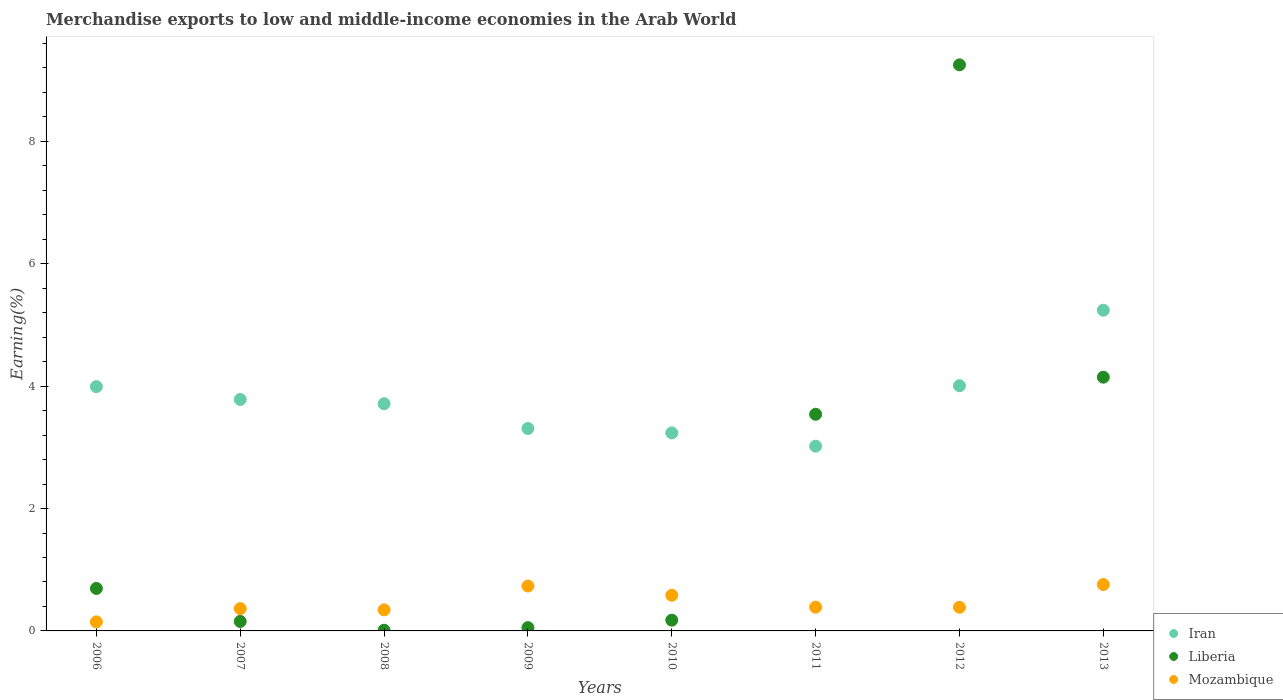What is the percentage of amount earned from merchandise exports in Mozambique in 2006?
Your answer should be compact. 0.15. Across all years, what is the maximum percentage of amount earned from merchandise exports in Mozambique?
Offer a terse response. 0.76. Across all years, what is the minimum percentage of amount earned from merchandise exports in Iran?
Keep it short and to the point. 3.02. In which year was the percentage of amount earned from merchandise exports in Mozambique minimum?
Keep it short and to the point. 2006. What is the total percentage of amount earned from merchandise exports in Liberia in the graph?
Give a very brief answer. 18.03. What is the difference between the percentage of amount earned from merchandise exports in Iran in 2007 and that in 2010?
Offer a very short reply. 0.55. What is the difference between the percentage of amount earned from merchandise exports in Mozambique in 2006 and the percentage of amount earned from merchandise exports in Liberia in 2008?
Your response must be concise. 0.14. What is the average percentage of amount earned from merchandise exports in Mozambique per year?
Provide a succinct answer. 0.46. In the year 2011, what is the difference between the percentage of amount earned from merchandise exports in Mozambique and percentage of amount earned from merchandise exports in Liberia?
Provide a succinct answer. -3.15. What is the ratio of the percentage of amount earned from merchandise exports in Mozambique in 2007 to that in 2013?
Provide a succinct answer. 0.48. What is the difference between the highest and the second highest percentage of amount earned from merchandise exports in Mozambique?
Offer a terse response. 0.02. What is the difference between the highest and the lowest percentage of amount earned from merchandise exports in Liberia?
Offer a very short reply. 9.24. Is it the case that in every year, the sum of the percentage of amount earned from merchandise exports in Iran and percentage of amount earned from merchandise exports in Mozambique  is greater than the percentage of amount earned from merchandise exports in Liberia?
Provide a short and direct response. No. Is the percentage of amount earned from merchandise exports in Mozambique strictly greater than the percentage of amount earned from merchandise exports in Iran over the years?
Offer a terse response. No. How many years are there in the graph?
Provide a succinct answer. 8. What is the difference between two consecutive major ticks on the Y-axis?
Give a very brief answer. 2. Where does the legend appear in the graph?
Ensure brevity in your answer.  Bottom right. How many legend labels are there?
Give a very brief answer. 3. What is the title of the graph?
Give a very brief answer. Merchandise exports to low and middle-income economies in the Arab World. Does "Least developed countries" appear as one of the legend labels in the graph?
Offer a terse response. No. What is the label or title of the X-axis?
Your answer should be very brief. Years. What is the label or title of the Y-axis?
Your response must be concise. Earning(%). What is the Earning(%) in Iran in 2006?
Give a very brief answer. 3.99. What is the Earning(%) in Liberia in 2006?
Offer a terse response. 0.69. What is the Earning(%) of Mozambique in 2006?
Make the answer very short. 0.15. What is the Earning(%) of Iran in 2007?
Offer a very short reply. 3.78. What is the Earning(%) of Liberia in 2007?
Offer a terse response. 0.15. What is the Earning(%) of Mozambique in 2007?
Make the answer very short. 0.36. What is the Earning(%) in Iran in 2008?
Make the answer very short. 3.71. What is the Earning(%) of Liberia in 2008?
Offer a terse response. 0.01. What is the Earning(%) of Mozambique in 2008?
Your answer should be compact. 0.34. What is the Earning(%) in Iran in 2009?
Make the answer very short. 3.31. What is the Earning(%) in Liberia in 2009?
Offer a terse response. 0.05. What is the Earning(%) of Mozambique in 2009?
Make the answer very short. 0.73. What is the Earning(%) of Iran in 2010?
Provide a short and direct response. 3.24. What is the Earning(%) in Liberia in 2010?
Provide a short and direct response. 0.18. What is the Earning(%) in Mozambique in 2010?
Give a very brief answer. 0.58. What is the Earning(%) in Iran in 2011?
Give a very brief answer. 3.02. What is the Earning(%) of Liberia in 2011?
Your answer should be compact. 3.54. What is the Earning(%) in Mozambique in 2011?
Your response must be concise. 0.39. What is the Earning(%) of Iran in 2012?
Keep it short and to the point. 4.01. What is the Earning(%) of Liberia in 2012?
Give a very brief answer. 9.25. What is the Earning(%) in Mozambique in 2012?
Offer a terse response. 0.39. What is the Earning(%) in Iran in 2013?
Ensure brevity in your answer.  5.24. What is the Earning(%) of Liberia in 2013?
Offer a terse response. 4.15. What is the Earning(%) in Mozambique in 2013?
Provide a short and direct response. 0.76. Across all years, what is the maximum Earning(%) of Iran?
Keep it short and to the point. 5.24. Across all years, what is the maximum Earning(%) of Liberia?
Offer a very short reply. 9.25. Across all years, what is the maximum Earning(%) in Mozambique?
Offer a very short reply. 0.76. Across all years, what is the minimum Earning(%) in Iran?
Offer a very short reply. 3.02. Across all years, what is the minimum Earning(%) of Liberia?
Keep it short and to the point. 0.01. Across all years, what is the minimum Earning(%) of Mozambique?
Ensure brevity in your answer.  0.15. What is the total Earning(%) in Iran in the graph?
Make the answer very short. 30.3. What is the total Earning(%) in Liberia in the graph?
Make the answer very short. 18.03. What is the total Earning(%) of Mozambique in the graph?
Ensure brevity in your answer.  3.71. What is the difference between the Earning(%) of Iran in 2006 and that in 2007?
Offer a terse response. 0.21. What is the difference between the Earning(%) in Liberia in 2006 and that in 2007?
Provide a succinct answer. 0.54. What is the difference between the Earning(%) of Mozambique in 2006 and that in 2007?
Provide a succinct answer. -0.22. What is the difference between the Earning(%) in Iran in 2006 and that in 2008?
Ensure brevity in your answer.  0.28. What is the difference between the Earning(%) of Liberia in 2006 and that in 2008?
Your answer should be very brief. 0.68. What is the difference between the Earning(%) of Mozambique in 2006 and that in 2008?
Offer a terse response. -0.2. What is the difference between the Earning(%) in Iran in 2006 and that in 2009?
Keep it short and to the point. 0.68. What is the difference between the Earning(%) in Liberia in 2006 and that in 2009?
Your answer should be compact. 0.64. What is the difference between the Earning(%) of Mozambique in 2006 and that in 2009?
Offer a terse response. -0.59. What is the difference between the Earning(%) in Iran in 2006 and that in 2010?
Offer a terse response. 0.76. What is the difference between the Earning(%) in Liberia in 2006 and that in 2010?
Your response must be concise. 0.52. What is the difference between the Earning(%) of Mozambique in 2006 and that in 2010?
Your response must be concise. -0.43. What is the difference between the Earning(%) of Iran in 2006 and that in 2011?
Offer a very short reply. 0.97. What is the difference between the Earning(%) of Liberia in 2006 and that in 2011?
Make the answer very short. -2.85. What is the difference between the Earning(%) in Mozambique in 2006 and that in 2011?
Provide a short and direct response. -0.24. What is the difference between the Earning(%) in Iran in 2006 and that in 2012?
Ensure brevity in your answer.  -0.01. What is the difference between the Earning(%) of Liberia in 2006 and that in 2012?
Provide a short and direct response. -8.56. What is the difference between the Earning(%) in Mozambique in 2006 and that in 2012?
Keep it short and to the point. -0.24. What is the difference between the Earning(%) in Iran in 2006 and that in 2013?
Give a very brief answer. -1.25. What is the difference between the Earning(%) of Liberia in 2006 and that in 2013?
Keep it short and to the point. -3.45. What is the difference between the Earning(%) of Mozambique in 2006 and that in 2013?
Make the answer very short. -0.61. What is the difference between the Earning(%) of Iran in 2007 and that in 2008?
Ensure brevity in your answer.  0.07. What is the difference between the Earning(%) in Liberia in 2007 and that in 2008?
Provide a short and direct response. 0.14. What is the difference between the Earning(%) in Mozambique in 2007 and that in 2008?
Provide a short and direct response. 0.02. What is the difference between the Earning(%) of Iran in 2007 and that in 2009?
Ensure brevity in your answer.  0.47. What is the difference between the Earning(%) in Liberia in 2007 and that in 2009?
Ensure brevity in your answer.  0.1. What is the difference between the Earning(%) in Mozambique in 2007 and that in 2009?
Provide a succinct answer. -0.37. What is the difference between the Earning(%) of Iran in 2007 and that in 2010?
Make the answer very short. 0.55. What is the difference between the Earning(%) of Liberia in 2007 and that in 2010?
Ensure brevity in your answer.  -0.02. What is the difference between the Earning(%) in Mozambique in 2007 and that in 2010?
Your answer should be compact. -0.22. What is the difference between the Earning(%) in Iran in 2007 and that in 2011?
Keep it short and to the point. 0.76. What is the difference between the Earning(%) in Liberia in 2007 and that in 2011?
Offer a terse response. -3.39. What is the difference between the Earning(%) of Mozambique in 2007 and that in 2011?
Make the answer very short. -0.02. What is the difference between the Earning(%) in Iran in 2007 and that in 2012?
Provide a succinct answer. -0.22. What is the difference between the Earning(%) in Liberia in 2007 and that in 2012?
Keep it short and to the point. -9.1. What is the difference between the Earning(%) in Mozambique in 2007 and that in 2012?
Keep it short and to the point. -0.02. What is the difference between the Earning(%) of Iran in 2007 and that in 2013?
Offer a terse response. -1.46. What is the difference between the Earning(%) of Liberia in 2007 and that in 2013?
Provide a succinct answer. -3.99. What is the difference between the Earning(%) in Mozambique in 2007 and that in 2013?
Offer a terse response. -0.39. What is the difference between the Earning(%) of Iran in 2008 and that in 2009?
Your answer should be very brief. 0.4. What is the difference between the Earning(%) in Liberia in 2008 and that in 2009?
Make the answer very short. -0.04. What is the difference between the Earning(%) in Mozambique in 2008 and that in 2009?
Give a very brief answer. -0.39. What is the difference between the Earning(%) of Iran in 2008 and that in 2010?
Your answer should be compact. 0.48. What is the difference between the Earning(%) in Liberia in 2008 and that in 2010?
Offer a very short reply. -0.16. What is the difference between the Earning(%) in Mozambique in 2008 and that in 2010?
Your answer should be very brief. -0.24. What is the difference between the Earning(%) of Iran in 2008 and that in 2011?
Make the answer very short. 0.69. What is the difference between the Earning(%) in Liberia in 2008 and that in 2011?
Provide a succinct answer. -3.53. What is the difference between the Earning(%) of Mozambique in 2008 and that in 2011?
Your response must be concise. -0.04. What is the difference between the Earning(%) in Iran in 2008 and that in 2012?
Provide a succinct answer. -0.29. What is the difference between the Earning(%) of Liberia in 2008 and that in 2012?
Offer a terse response. -9.24. What is the difference between the Earning(%) in Mozambique in 2008 and that in 2012?
Keep it short and to the point. -0.04. What is the difference between the Earning(%) of Iran in 2008 and that in 2013?
Offer a very short reply. -1.53. What is the difference between the Earning(%) in Liberia in 2008 and that in 2013?
Your answer should be very brief. -4.13. What is the difference between the Earning(%) of Mozambique in 2008 and that in 2013?
Your answer should be very brief. -0.41. What is the difference between the Earning(%) of Iran in 2009 and that in 2010?
Offer a very short reply. 0.07. What is the difference between the Earning(%) of Liberia in 2009 and that in 2010?
Give a very brief answer. -0.12. What is the difference between the Earning(%) of Mozambique in 2009 and that in 2010?
Offer a terse response. 0.15. What is the difference between the Earning(%) of Iran in 2009 and that in 2011?
Your response must be concise. 0.29. What is the difference between the Earning(%) in Liberia in 2009 and that in 2011?
Provide a short and direct response. -3.49. What is the difference between the Earning(%) in Mozambique in 2009 and that in 2011?
Your answer should be very brief. 0.34. What is the difference between the Earning(%) of Iran in 2009 and that in 2012?
Ensure brevity in your answer.  -0.7. What is the difference between the Earning(%) in Liberia in 2009 and that in 2012?
Your answer should be compact. -9.2. What is the difference between the Earning(%) of Mozambique in 2009 and that in 2012?
Provide a succinct answer. 0.35. What is the difference between the Earning(%) of Iran in 2009 and that in 2013?
Ensure brevity in your answer.  -1.93. What is the difference between the Earning(%) of Liberia in 2009 and that in 2013?
Your response must be concise. -4.09. What is the difference between the Earning(%) of Mozambique in 2009 and that in 2013?
Your response must be concise. -0.02. What is the difference between the Earning(%) of Iran in 2010 and that in 2011?
Provide a succinct answer. 0.22. What is the difference between the Earning(%) of Liberia in 2010 and that in 2011?
Make the answer very short. -3.37. What is the difference between the Earning(%) of Mozambique in 2010 and that in 2011?
Your answer should be compact. 0.19. What is the difference between the Earning(%) in Iran in 2010 and that in 2012?
Give a very brief answer. -0.77. What is the difference between the Earning(%) in Liberia in 2010 and that in 2012?
Give a very brief answer. -9.08. What is the difference between the Earning(%) of Mozambique in 2010 and that in 2012?
Ensure brevity in your answer.  0.2. What is the difference between the Earning(%) in Iran in 2010 and that in 2013?
Your response must be concise. -2. What is the difference between the Earning(%) in Liberia in 2010 and that in 2013?
Your answer should be very brief. -3.97. What is the difference between the Earning(%) of Mozambique in 2010 and that in 2013?
Your answer should be very brief. -0.18. What is the difference between the Earning(%) of Iran in 2011 and that in 2012?
Make the answer very short. -0.99. What is the difference between the Earning(%) of Liberia in 2011 and that in 2012?
Offer a terse response. -5.71. What is the difference between the Earning(%) of Mozambique in 2011 and that in 2012?
Give a very brief answer. 0. What is the difference between the Earning(%) of Iran in 2011 and that in 2013?
Offer a very short reply. -2.22. What is the difference between the Earning(%) in Liberia in 2011 and that in 2013?
Give a very brief answer. -0.61. What is the difference between the Earning(%) of Mozambique in 2011 and that in 2013?
Give a very brief answer. -0.37. What is the difference between the Earning(%) in Iran in 2012 and that in 2013?
Keep it short and to the point. -1.23. What is the difference between the Earning(%) of Liberia in 2012 and that in 2013?
Keep it short and to the point. 5.1. What is the difference between the Earning(%) in Mozambique in 2012 and that in 2013?
Provide a short and direct response. -0.37. What is the difference between the Earning(%) of Iran in 2006 and the Earning(%) of Liberia in 2007?
Make the answer very short. 3.84. What is the difference between the Earning(%) of Iran in 2006 and the Earning(%) of Mozambique in 2007?
Keep it short and to the point. 3.63. What is the difference between the Earning(%) in Liberia in 2006 and the Earning(%) in Mozambique in 2007?
Ensure brevity in your answer.  0.33. What is the difference between the Earning(%) of Iran in 2006 and the Earning(%) of Liberia in 2008?
Give a very brief answer. 3.98. What is the difference between the Earning(%) of Iran in 2006 and the Earning(%) of Mozambique in 2008?
Your answer should be compact. 3.65. What is the difference between the Earning(%) in Liberia in 2006 and the Earning(%) in Mozambique in 2008?
Provide a succinct answer. 0.35. What is the difference between the Earning(%) in Iran in 2006 and the Earning(%) in Liberia in 2009?
Ensure brevity in your answer.  3.94. What is the difference between the Earning(%) in Iran in 2006 and the Earning(%) in Mozambique in 2009?
Offer a terse response. 3.26. What is the difference between the Earning(%) in Liberia in 2006 and the Earning(%) in Mozambique in 2009?
Provide a short and direct response. -0.04. What is the difference between the Earning(%) of Iran in 2006 and the Earning(%) of Liberia in 2010?
Keep it short and to the point. 3.82. What is the difference between the Earning(%) of Iran in 2006 and the Earning(%) of Mozambique in 2010?
Make the answer very short. 3.41. What is the difference between the Earning(%) of Liberia in 2006 and the Earning(%) of Mozambique in 2010?
Your answer should be compact. 0.11. What is the difference between the Earning(%) of Iran in 2006 and the Earning(%) of Liberia in 2011?
Your response must be concise. 0.45. What is the difference between the Earning(%) in Iran in 2006 and the Earning(%) in Mozambique in 2011?
Offer a terse response. 3.6. What is the difference between the Earning(%) of Liberia in 2006 and the Earning(%) of Mozambique in 2011?
Provide a short and direct response. 0.31. What is the difference between the Earning(%) in Iran in 2006 and the Earning(%) in Liberia in 2012?
Provide a short and direct response. -5.26. What is the difference between the Earning(%) in Iran in 2006 and the Earning(%) in Mozambique in 2012?
Your answer should be very brief. 3.61. What is the difference between the Earning(%) of Liberia in 2006 and the Earning(%) of Mozambique in 2012?
Provide a short and direct response. 0.31. What is the difference between the Earning(%) in Iran in 2006 and the Earning(%) in Liberia in 2013?
Your answer should be very brief. -0.15. What is the difference between the Earning(%) of Iran in 2006 and the Earning(%) of Mozambique in 2013?
Offer a terse response. 3.23. What is the difference between the Earning(%) in Liberia in 2006 and the Earning(%) in Mozambique in 2013?
Keep it short and to the point. -0.06. What is the difference between the Earning(%) in Iran in 2007 and the Earning(%) in Liberia in 2008?
Offer a very short reply. 3.77. What is the difference between the Earning(%) of Iran in 2007 and the Earning(%) of Mozambique in 2008?
Your response must be concise. 3.44. What is the difference between the Earning(%) of Liberia in 2007 and the Earning(%) of Mozambique in 2008?
Your response must be concise. -0.19. What is the difference between the Earning(%) in Iran in 2007 and the Earning(%) in Liberia in 2009?
Ensure brevity in your answer.  3.73. What is the difference between the Earning(%) of Iran in 2007 and the Earning(%) of Mozambique in 2009?
Your response must be concise. 3.05. What is the difference between the Earning(%) of Liberia in 2007 and the Earning(%) of Mozambique in 2009?
Keep it short and to the point. -0.58. What is the difference between the Earning(%) in Iran in 2007 and the Earning(%) in Liberia in 2010?
Make the answer very short. 3.61. What is the difference between the Earning(%) in Iran in 2007 and the Earning(%) in Mozambique in 2010?
Your answer should be very brief. 3.2. What is the difference between the Earning(%) of Liberia in 2007 and the Earning(%) of Mozambique in 2010?
Offer a terse response. -0.43. What is the difference between the Earning(%) of Iran in 2007 and the Earning(%) of Liberia in 2011?
Give a very brief answer. 0.24. What is the difference between the Earning(%) in Iran in 2007 and the Earning(%) in Mozambique in 2011?
Ensure brevity in your answer.  3.39. What is the difference between the Earning(%) in Liberia in 2007 and the Earning(%) in Mozambique in 2011?
Offer a very short reply. -0.23. What is the difference between the Earning(%) of Iran in 2007 and the Earning(%) of Liberia in 2012?
Keep it short and to the point. -5.47. What is the difference between the Earning(%) of Iran in 2007 and the Earning(%) of Mozambique in 2012?
Offer a very short reply. 3.4. What is the difference between the Earning(%) of Liberia in 2007 and the Earning(%) of Mozambique in 2012?
Your answer should be very brief. -0.23. What is the difference between the Earning(%) of Iran in 2007 and the Earning(%) of Liberia in 2013?
Your answer should be compact. -0.36. What is the difference between the Earning(%) of Iran in 2007 and the Earning(%) of Mozambique in 2013?
Provide a succinct answer. 3.02. What is the difference between the Earning(%) in Liberia in 2007 and the Earning(%) in Mozambique in 2013?
Keep it short and to the point. -0.6. What is the difference between the Earning(%) of Iran in 2008 and the Earning(%) of Liberia in 2009?
Provide a short and direct response. 3.66. What is the difference between the Earning(%) in Iran in 2008 and the Earning(%) in Mozambique in 2009?
Your answer should be compact. 2.98. What is the difference between the Earning(%) of Liberia in 2008 and the Earning(%) of Mozambique in 2009?
Give a very brief answer. -0.72. What is the difference between the Earning(%) of Iran in 2008 and the Earning(%) of Liberia in 2010?
Provide a succinct answer. 3.54. What is the difference between the Earning(%) in Iran in 2008 and the Earning(%) in Mozambique in 2010?
Provide a succinct answer. 3.13. What is the difference between the Earning(%) in Liberia in 2008 and the Earning(%) in Mozambique in 2010?
Provide a succinct answer. -0.57. What is the difference between the Earning(%) of Iran in 2008 and the Earning(%) of Liberia in 2011?
Your answer should be compact. 0.17. What is the difference between the Earning(%) of Iran in 2008 and the Earning(%) of Mozambique in 2011?
Offer a terse response. 3.32. What is the difference between the Earning(%) in Liberia in 2008 and the Earning(%) in Mozambique in 2011?
Give a very brief answer. -0.38. What is the difference between the Earning(%) of Iran in 2008 and the Earning(%) of Liberia in 2012?
Your answer should be very brief. -5.54. What is the difference between the Earning(%) in Iran in 2008 and the Earning(%) in Mozambique in 2012?
Offer a very short reply. 3.33. What is the difference between the Earning(%) in Liberia in 2008 and the Earning(%) in Mozambique in 2012?
Ensure brevity in your answer.  -0.37. What is the difference between the Earning(%) of Iran in 2008 and the Earning(%) of Liberia in 2013?
Give a very brief answer. -0.43. What is the difference between the Earning(%) of Iran in 2008 and the Earning(%) of Mozambique in 2013?
Offer a terse response. 2.95. What is the difference between the Earning(%) in Liberia in 2008 and the Earning(%) in Mozambique in 2013?
Provide a short and direct response. -0.75. What is the difference between the Earning(%) of Iran in 2009 and the Earning(%) of Liberia in 2010?
Make the answer very short. 3.13. What is the difference between the Earning(%) in Iran in 2009 and the Earning(%) in Mozambique in 2010?
Keep it short and to the point. 2.73. What is the difference between the Earning(%) of Liberia in 2009 and the Earning(%) of Mozambique in 2010?
Your response must be concise. -0.53. What is the difference between the Earning(%) in Iran in 2009 and the Earning(%) in Liberia in 2011?
Provide a succinct answer. -0.23. What is the difference between the Earning(%) of Iran in 2009 and the Earning(%) of Mozambique in 2011?
Your answer should be compact. 2.92. What is the difference between the Earning(%) of Liberia in 2009 and the Earning(%) of Mozambique in 2011?
Ensure brevity in your answer.  -0.34. What is the difference between the Earning(%) in Iran in 2009 and the Earning(%) in Liberia in 2012?
Your response must be concise. -5.94. What is the difference between the Earning(%) in Iran in 2009 and the Earning(%) in Mozambique in 2012?
Ensure brevity in your answer.  2.92. What is the difference between the Earning(%) in Liberia in 2009 and the Earning(%) in Mozambique in 2012?
Your response must be concise. -0.33. What is the difference between the Earning(%) in Iran in 2009 and the Earning(%) in Liberia in 2013?
Make the answer very short. -0.84. What is the difference between the Earning(%) in Iran in 2009 and the Earning(%) in Mozambique in 2013?
Offer a terse response. 2.55. What is the difference between the Earning(%) of Liberia in 2009 and the Earning(%) of Mozambique in 2013?
Offer a terse response. -0.7. What is the difference between the Earning(%) in Iran in 2010 and the Earning(%) in Liberia in 2011?
Your response must be concise. -0.3. What is the difference between the Earning(%) of Iran in 2010 and the Earning(%) of Mozambique in 2011?
Provide a short and direct response. 2.85. What is the difference between the Earning(%) of Liberia in 2010 and the Earning(%) of Mozambique in 2011?
Give a very brief answer. -0.21. What is the difference between the Earning(%) of Iran in 2010 and the Earning(%) of Liberia in 2012?
Make the answer very short. -6.01. What is the difference between the Earning(%) of Iran in 2010 and the Earning(%) of Mozambique in 2012?
Provide a short and direct response. 2.85. What is the difference between the Earning(%) of Liberia in 2010 and the Earning(%) of Mozambique in 2012?
Ensure brevity in your answer.  -0.21. What is the difference between the Earning(%) of Iran in 2010 and the Earning(%) of Liberia in 2013?
Offer a very short reply. -0.91. What is the difference between the Earning(%) in Iran in 2010 and the Earning(%) in Mozambique in 2013?
Your response must be concise. 2.48. What is the difference between the Earning(%) in Liberia in 2010 and the Earning(%) in Mozambique in 2013?
Your answer should be very brief. -0.58. What is the difference between the Earning(%) of Iran in 2011 and the Earning(%) of Liberia in 2012?
Your answer should be compact. -6.23. What is the difference between the Earning(%) of Iran in 2011 and the Earning(%) of Mozambique in 2012?
Ensure brevity in your answer.  2.63. What is the difference between the Earning(%) of Liberia in 2011 and the Earning(%) of Mozambique in 2012?
Your answer should be compact. 3.15. What is the difference between the Earning(%) in Iran in 2011 and the Earning(%) in Liberia in 2013?
Offer a terse response. -1.13. What is the difference between the Earning(%) of Iran in 2011 and the Earning(%) of Mozambique in 2013?
Your answer should be very brief. 2.26. What is the difference between the Earning(%) in Liberia in 2011 and the Earning(%) in Mozambique in 2013?
Keep it short and to the point. 2.78. What is the difference between the Earning(%) in Iran in 2012 and the Earning(%) in Liberia in 2013?
Offer a terse response. -0.14. What is the difference between the Earning(%) of Iran in 2012 and the Earning(%) of Mozambique in 2013?
Keep it short and to the point. 3.25. What is the difference between the Earning(%) of Liberia in 2012 and the Earning(%) of Mozambique in 2013?
Your answer should be compact. 8.49. What is the average Earning(%) in Iran per year?
Make the answer very short. 3.79. What is the average Earning(%) in Liberia per year?
Offer a terse response. 2.25. What is the average Earning(%) in Mozambique per year?
Ensure brevity in your answer.  0.46. In the year 2006, what is the difference between the Earning(%) in Iran and Earning(%) in Liberia?
Keep it short and to the point. 3.3. In the year 2006, what is the difference between the Earning(%) in Iran and Earning(%) in Mozambique?
Offer a very short reply. 3.84. In the year 2006, what is the difference between the Earning(%) of Liberia and Earning(%) of Mozambique?
Keep it short and to the point. 0.55. In the year 2007, what is the difference between the Earning(%) of Iran and Earning(%) of Liberia?
Keep it short and to the point. 3.63. In the year 2007, what is the difference between the Earning(%) of Iran and Earning(%) of Mozambique?
Offer a very short reply. 3.42. In the year 2007, what is the difference between the Earning(%) of Liberia and Earning(%) of Mozambique?
Make the answer very short. -0.21. In the year 2008, what is the difference between the Earning(%) in Iran and Earning(%) in Liberia?
Provide a succinct answer. 3.7. In the year 2008, what is the difference between the Earning(%) of Iran and Earning(%) of Mozambique?
Ensure brevity in your answer.  3.37. In the year 2008, what is the difference between the Earning(%) of Liberia and Earning(%) of Mozambique?
Keep it short and to the point. -0.33. In the year 2009, what is the difference between the Earning(%) of Iran and Earning(%) of Liberia?
Your answer should be very brief. 3.25. In the year 2009, what is the difference between the Earning(%) in Iran and Earning(%) in Mozambique?
Keep it short and to the point. 2.57. In the year 2009, what is the difference between the Earning(%) of Liberia and Earning(%) of Mozambique?
Ensure brevity in your answer.  -0.68. In the year 2010, what is the difference between the Earning(%) of Iran and Earning(%) of Liberia?
Make the answer very short. 3.06. In the year 2010, what is the difference between the Earning(%) of Iran and Earning(%) of Mozambique?
Ensure brevity in your answer.  2.65. In the year 2010, what is the difference between the Earning(%) in Liberia and Earning(%) in Mozambique?
Offer a terse response. -0.41. In the year 2011, what is the difference between the Earning(%) of Iran and Earning(%) of Liberia?
Make the answer very short. -0.52. In the year 2011, what is the difference between the Earning(%) in Iran and Earning(%) in Mozambique?
Offer a very short reply. 2.63. In the year 2011, what is the difference between the Earning(%) of Liberia and Earning(%) of Mozambique?
Provide a succinct answer. 3.15. In the year 2012, what is the difference between the Earning(%) in Iran and Earning(%) in Liberia?
Provide a succinct answer. -5.24. In the year 2012, what is the difference between the Earning(%) in Iran and Earning(%) in Mozambique?
Offer a very short reply. 3.62. In the year 2012, what is the difference between the Earning(%) in Liberia and Earning(%) in Mozambique?
Give a very brief answer. 8.86. In the year 2013, what is the difference between the Earning(%) of Iran and Earning(%) of Liberia?
Offer a very short reply. 1.09. In the year 2013, what is the difference between the Earning(%) of Iran and Earning(%) of Mozambique?
Offer a very short reply. 4.48. In the year 2013, what is the difference between the Earning(%) in Liberia and Earning(%) in Mozambique?
Keep it short and to the point. 3.39. What is the ratio of the Earning(%) in Iran in 2006 to that in 2007?
Keep it short and to the point. 1.06. What is the ratio of the Earning(%) in Liberia in 2006 to that in 2007?
Your answer should be compact. 4.49. What is the ratio of the Earning(%) in Mozambique in 2006 to that in 2007?
Provide a short and direct response. 0.41. What is the ratio of the Earning(%) in Iran in 2006 to that in 2008?
Give a very brief answer. 1.08. What is the ratio of the Earning(%) of Liberia in 2006 to that in 2008?
Keep it short and to the point. 58.15. What is the ratio of the Earning(%) in Mozambique in 2006 to that in 2008?
Give a very brief answer. 0.43. What is the ratio of the Earning(%) of Iran in 2006 to that in 2009?
Your answer should be compact. 1.21. What is the ratio of the Earning(%) in Liberia in 2006 to that in 2009?
Your answer should be compact. 12.94. What is the ratio of the Earning(%) of Mozambique in 2006 to that in 2009?
Make the answer very short. 0.2. What is the ratio of the Earning(%) in Iran in 2006 to that in 2010?
Give a very brief answer. 1.23. What is the ratio of the Earning(%) of Liberia in 2006 to that in 2010?
Your answer should be compact. 3.95. What is the ratio of the Earning(%) in Mozambique in 2006 to that in 2010?
Offer a terse response. 0.25. What is the ratio of the Earning(%) in Iran in 2006 to that in 2011?
Ensure brevity in your answer.  1.32. What is the ratio of the Earning(%) in Liberia in 2006 to that in 2011?
Offer a terse response. 0.2. What is the ratio of the Earning(%) of Mozambique in 2006 to that in 2011?
Offer a terse response. 0.38. What is the ratio of the Earning(%) in Liberia in 2006 to that in 2012?
Offer a very short reply. 0.07. What is the ratio of the Earning(%) in Mozambique in 2006 to that in 2012?
Offer a terse response. 0.38. What is the ratio of the Earning(%) in Iran in 2006 to that in 2013?
Your answer should be compact. 0.76. What is the ratio of the Earning(%) in Liberia in 2006 to that in 2013?
Offer a very short reply. 0.17. What is the ratio of the Earning(%) of Mozambique in 2006 to that in 2013?
Ensure brevity in your answer.  0.2. What is the ratio of the Earning(%) of Iran in 2007 to that in 2008?
Your response must be concise. 1.02. What is the ratio of the Earning(%) of Liberia in 2007 to that in 2008?
Offer a terse response. 12.95. What is the ratio of the Earning(%) in Mozambique in 2007 to that in 2008?
Your response must be concise. 1.06. What is the ratio of the Earning(%) of Iran in 2007 to that in 2009?
Provide a short and direct response. 1.14. What is the ratio of the Earning(%) of Liberia in 2007 to that in 2009?
Keep it short and to the point. 2.88. What is the ratio of the Earning(%) in Mozambique in 2007 to that in 2009?
Give a very brief answer. 0.5. What is the ratio of the Earning(%) in Iran in 2007 to that in 2010?
Provide a succinct answer. 1.17. What is the ratio of the Earning(%) of Liberia in 2007 to that in 2010?
Offer a very short reply. 0.88. What is the ratio of the Earning(%) of Mozambique in 2007 to that in 2010?
Ensure brevity in your answer.  0.63. What is the ratio of the Earning(%) in Iran in 2007 to that in 2011?
Provide a succinct answer. 1.25. What is the ratio of the Earning(%) in Liberia in 2007 to that in 2011?
Your answer should be very brief. 0.04. What is the ratio of the Earning(%) in Mozambique in 2007 to that in 2011?
Your answer should be very brief. 0.94. What is the ratio of the Earning(%) of Iran in 2007 to that in 2012?
Your answer should be compact. 0.94. What is the ratio of the Earning(%) in Liberia in 2007 to that in 2012?
Your answer should be compact. 0.02. What is the ratio of the Earning(%) in Mozambique in 2007 to that in 2012?
Offer a very short reply. 0.94. What is the ratio of the Earning(%) in Iran in 2007 to that in 2013?
Ensure brevity in your answer.  0.72. What is the ratio of the Earning(%) of Liberia in 2007 to that in 2013?
Make the answer very short. 0.04. What is the ratio of the Earning(%) in Mozambique in 2007 to that in 2013?
Provide a succinct answer. 0.48. What is the ratio of the Earning(%) of Iran in 2008 to that in 2009?
Ensure brevity in your answer.  1.12. What is the ratio of the Earning(%) in Liberia in 2008 to that in 2009?
Your answer should be compact. 0.22. What is the ratio of the Earning(%) of Mozambique in 2008 to that in 2009?
Ensure brevity in your answer.  0.47. What is the ratio of the Earning(%) in Iran in 2008 to that in 2010?
Make the answer very short. 1.15. What is the ratio of the Earning(%) in Liberia in 2008 to that in 2010?
Your answer should be compact. 0.07. What is the ratio of the Earning(%) of Mozambique in 2008 to that in 2010?
Ensure brevity in your answer.  0.59. What is the ratio of the Earning(%) in Iran in 2008 to that in 2011?
Provide a succinct answer. 1.23. What is the ratio of the Earning(%) in Liberia in 2008 to that in 2011?
Keep it short and to the point. 0. What is the ratio of the Earning(%) in Mozambique in 2008 to that in 2011?
Ensure brevity in your answer.  0.89. What is the ratio of the Earning(%) of Iran in 2008 to that in 2012?
Keep it short and to the point. 0.93. What is the ratio of the Earning(%) of Liberia in 2008 to that in 2012?
Give a very brief answer. 0. What is the ratio of the Earning(%) in Mozambique in 2008 to that in 2012?
Your response must be concise. 0.89. What is the ratio of the Earning(%) of Iran in 2008 to that in 2013?
Give a very brief answer. 0.71. What is the ratio of the Earning(%) of Liberia in 2008 to that in 2013?
Provide a short and direct response. 0. What is the ratio of the Earning(%) of Mozambique in 2008 to that in 2013?
Your answer should be very brief. 0.45. What is the ratio of the Earning(%) of Iran in 2009 to that in 2010?
Ensure brevity in your answer.  1.02. What is the ratio of the Earning(%) of Liberia in 2009 to that in 2010?
Provide a short and direct response. 0.31. What is the ratio of the Earning(%) of Mozambique in 2009 to that in 2010?
Your response must be concise. 1.26. What is the ratio of the Earning(%) of Iran in 2009 to that in 2011?
Your answer should be compact. 1.1. What is the ratio of the Earning(%) in Liberia in 2009 to that in 2011?
Provide a short and direct response. 0.02. What is the ratio of the Earning(%) of Mozambique in 2009 to that in 2011?
Ensure brevity in your answer.  1.89. What is the ratio of the Earning(%) of Iran in 2009 to that in 2012?
Your answer should be very brief. 0.83. What is the ratio of the Earning(%) in Liberia in 2009 to that in 2012?
Your answer should be very brief. 0.01. What is the ratio of the Earning(%) of Mozambique in 2009 to that in 2012?
Make the answer very short. 1.9. What is the ratio of the Earning(%) of Iran in 2009 to that in 2013?
Offer a very short reply. 0.63. What is the ratio of the Earning(%) of Liberia in 2009 to that in 2013?
Make the answer very short. 0.01. What is the ratio of the Earning(%) in Mozambique in 2009 to that in 2013?
Ensure brevity in your answer.  0.97. What is the ratio of the Earning(%) of Iran in 2010 to that in 2011?
Your answer should be very brief. 1.07. What is the ratio of the Earning(%) of Liberia in 2010 to that in 2011?
Your answer should be very brief. 0.05. What is the ratio of the Earning(%) of Mozambique in 2010 to that in 2011?
Your answer should be very brief. 1.5. What is the ratio of the Earning(%) of Iran in 2010 to that in 2012?
Ensure brevity in your answer.  0.81. What is the ratio of the Earning(%) of Liberia in 2010 to that in 2012?
Your response must be concise. 0.02. What is the ratio of the Earning(%) of Mozambique in 2010 to that in 2012?
Keep it short and to the point. 1.51. What is the ratio of the Earning(%) in Iran in 2010 to that in 2013?
Keep it short and to the point. 0.62. What is the ratio of the Earning(%) of Liberia in 2010 to that in 2013?
Make the answer very short. 0.04. What is the ratio of the Earning(%) in Mozambique in 2010 to that in 2013?
Make the answer very short. 0.77. What is the ratio of the Earning(%) in Iran in 2011 to that in 2012?
Keep it short and to the point. 0.75. What is the ratio of the Earning(%) in Liberia in 2011 to that in 2012?
Make the answer very short. 0.38. What is the ratio of the Earning(%) in Iran in 2011 to that in 2013?
Give a very brief answer. 0.58. What is the ratio of the Earning(%) of Liberia in 2011 to that in 2013?
Make the answer very short. 0.85. What is the ratio of the Earning(%) of Mozambique in 2011 to that in 2013?
Your answer should be very brief. 0.51. What is the ratio of the Earning(%) in Iran in 2012 to that in 2013?
Give a very brief answer. 0.76. What is the ratio of the Earning(%) in Liberia in 2012 to that in 2013?
Your response must be concise. 2.23. What is the ratio of the Earning(%) of Mozambique in 2012 to that in 2013?
Provide a succinct answer. 0.51. What is the difference between the highest and the second highest Earning(%) of Iran?
Your response must be concise. 1.23. What is the difference between the highest and the second highest Earning(%) of Liberia?
Keep it short and to the point. 5.1. What is the difference between the highest and the second highest Earning(%) in Mozambique?
Your answer should be compact. 0.02. What is the difference between the highest and the lowest Earning(%) in Iran?
Your response must be concise. 2.22. What is the difference between the highest and the lowest Earning(%) of Liberia?
Provide a short and direct response. 9.24. What is the difference between the highest and the lowest Earning(%) of Mozambique?
Offer a very short reply. 0.61. 